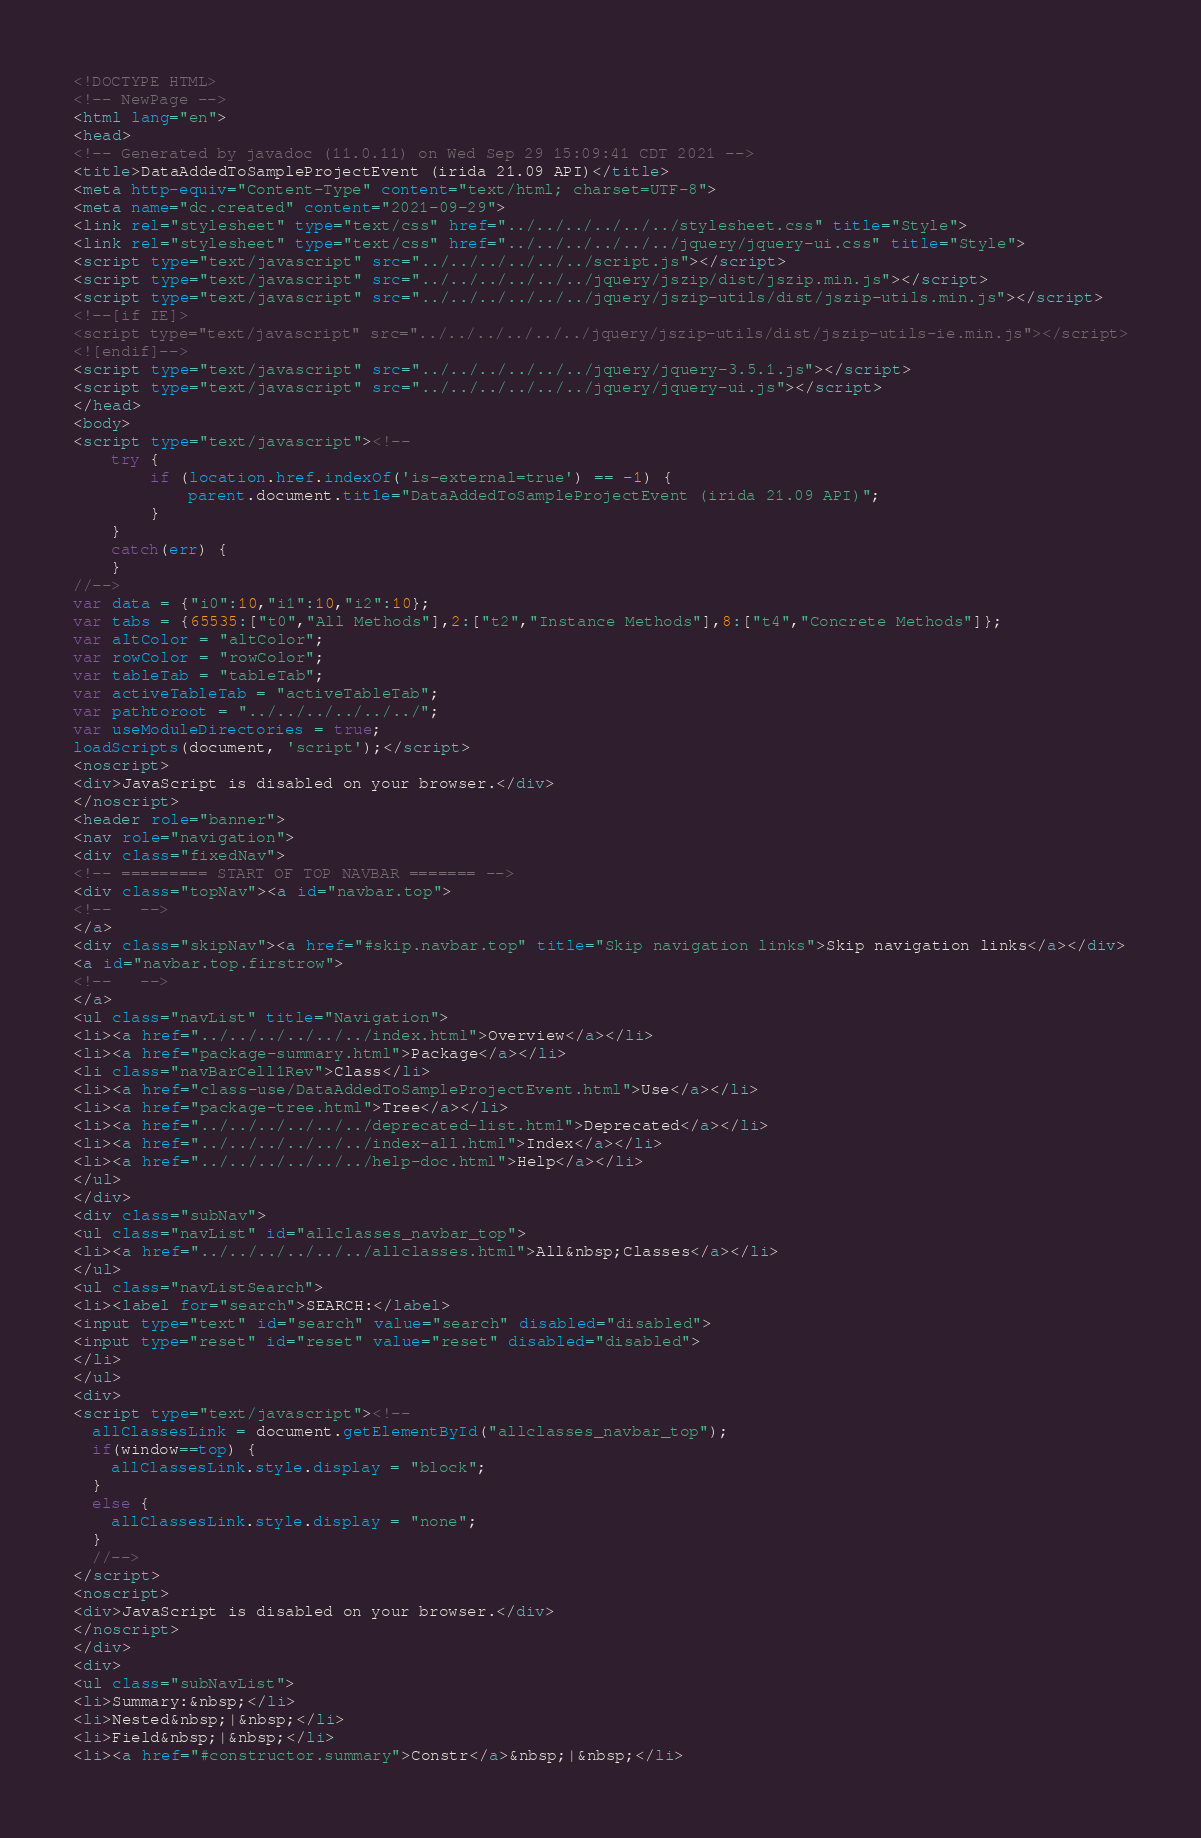<code> <loc_0><loc_0><loc_500><loc_500><_HTML_><!DOCTYPE HTML>
<!-- NewPage -->
<html lang="en">
<head>
<!-- Generated by javadoc (11.0.11) on Wed Sep 29 15:09:41 CDT 2021 -->
<title>DataAddedToSampleProjectEvent (irida 21.09 API)</title>
<meta http-equiv="Content-Type" content="text/html; charset=UTF-8">
<meta name="dc.created" content="2021-09-29">
<link rel="stylesheet" type="text/css" href="../../../../../../stylesheet.css" title="Style">
<link rel="stylesheet" type="text/css" href="../../../../../../jquery/jquery-ui.css" title="Style">
<script type="text/javascript" src="../../../../../../script.js"></script>
<script type="text/javascript" src="../../../../../../jquery/jszip/dist/jszip.min.js"></script>
<script type="text/javascript" src="../../../../../../jquery/jszip-utils/dist/jszip-utils.min.js"></script>
<!--[if IE]>
<script type="text/javascript" src="../../../../../../jquery/jszip-utils/dist/jszip-utils-ie.min.js"></script>
<![endif]-->
<script type="text/javascript" src="../../../../../../jquery/jquery-3.5.1.js"></script>
<script type="text/javascript" src="../../../../../../jquery/jquery-ui.js"></script>
</head>
<body>
<script type="text/javascript"><!--
    try {
        if (location.href.indexOf('is-external=true') == -1) {
            parent.document.title="DataAddedToSampleProjectEvent (irida 21.09 API)";
        }
    }
    catch(err) {
    }
//-->
var data = {"i0":10,"i1":10,"i2":10};
var tabs = {65535:["t0","All Methods"],2:["t2","Instance Methods"],8:["t4","Concrete Methods"]};
var altColor = "altColor";
var rowColor = "rowColor";
var tableTab = "tableTab";
var activeTableTab = "activeTableTab";
var pathtoroot = "../../../../../../";
var useModuleDirectories = true;
loadScripts(document, 'script');</script>
<noscript>
<div>JavaScript is disabled on your browser.</div>
</noscript>
<header role="banner">
<nav role="navigation">
<div class="fixedNav">
<!-- ========= START OF TOP NAVBAR ======= -->
<div class="topNav"><a id="navbar.top">
<!--   -->
</a>
<div class="skipNav"><a href="#skip.navbar.top" title="Skip navigation links">Skip navigation links</a></div>
<a id="navbar.top.firstrow">
<!--   -->
</a>
<ul class="navList" title="Navigation">
<li><a href="../../../../../../index.html">Overview</a></li>
<li><a href="package-summary.html">Package</a></li>
<li class="navBarCell1Rev">Class</li>
<li><a href="class-use/DataAddedToSampleProjectEvent.html">Use</a></li>
<li><a href="package-tree.html">Tree</a></li>
<li><a href="../../../../../../deprecated-list.html">Deprecated</a></li>
<li><a href="../../../../../../index-all.html">Index</a></li>
<li><a href="../../../../../../help-doc.html">Help</a></li>
</ul>
</div>
<div class="subNav">
<ul class="navList" id="allclasses_navbar_top">
<li><a href="../../../../../../allclasses.html">All&nbsp;Classes</a></li>
</ul>
<ul class="navListSearch">
<li><label for="search">SEARCH:</label>
<input type="text" id="search" value="search" disabled="disabled">
<input type="reset" id="reset" value="reset" disabled="disabled">
</li>
</ul>
<div>
<script type="text/javascript"><!--
  allClassesLink = document.getElementById("allclasses_navbar_top");
  if(window==top) {
    allClassesLink.style.display = "block";
  }
  else {
    allClassesLink.style.display = "none";
  }
  //-->
</script>
<noscript>
<div>JavaScript is disabled on your browser.</div>
</noscript>
</div>
<div>
<ul class="subNavList">
<li>Summary:&nbsp;</li>
<li>Nested&nbsp;|&nbsp;</li>
<li>Field&nbsp;|&nbsp;</li>
<li><a href="#constructor.summary">Constr</a>&nbsp;|&nbsp;</li></code> 